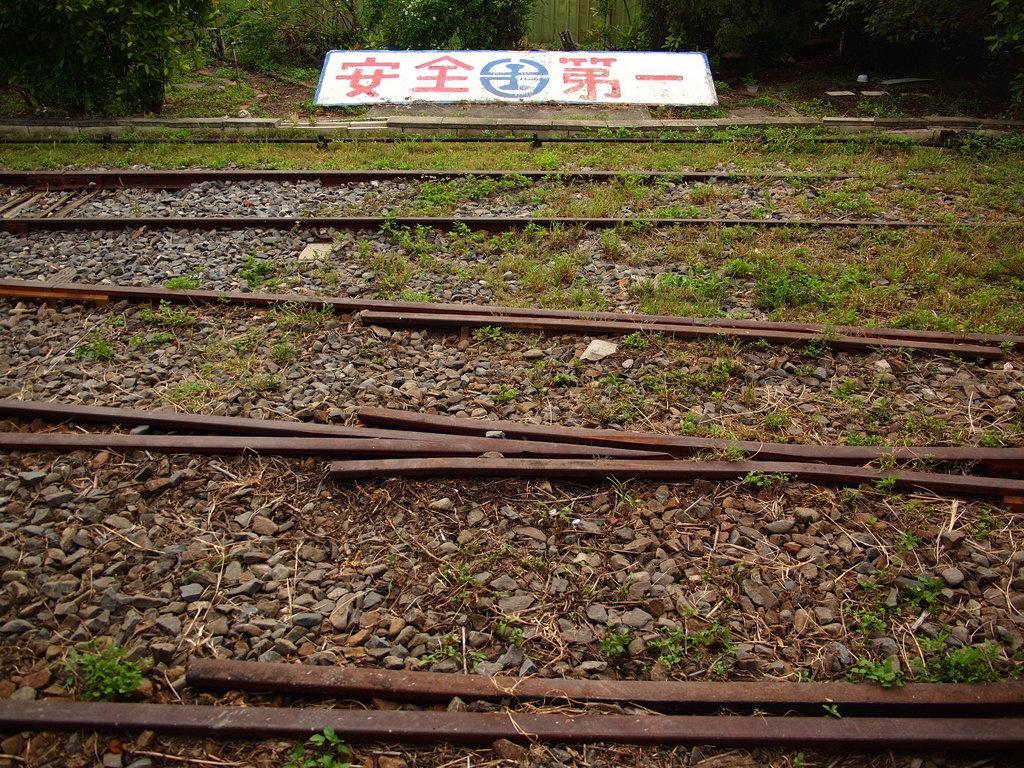Can you describe this image briefly? In this picture we can see some stones, railway tracks and grass at the bottom, in the background there are some plants and a board. 